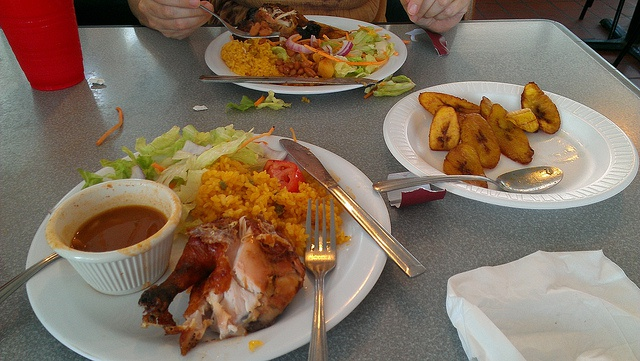Describe the objects in this image and their specific colors. I can see dining table in gray, darkgray, maroon, and brown tones, bowl in maroon, darkgray, tan, and gray tones, banana in maroon, brown, and darkgray tones, cup in maroon, gray, and darkgray tones, and people in maroon and gray tones in this image. 